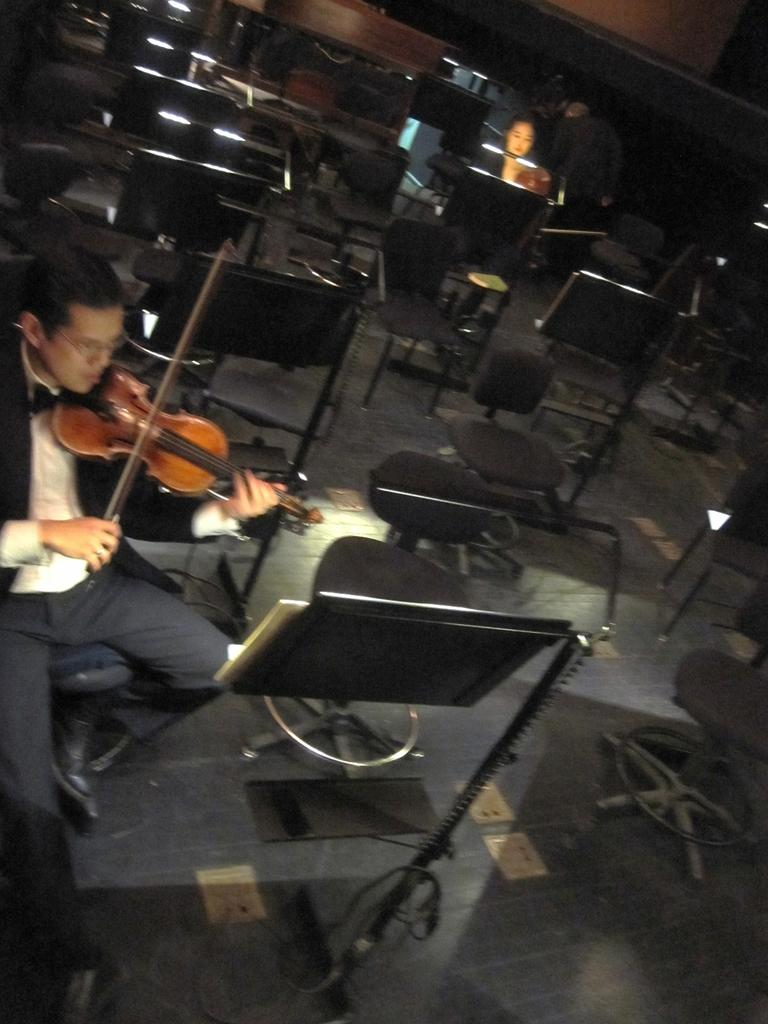What is the woman in the image doing? The woman is playing the violin in the image. Is the woman focused on anything while playing the violin? Yes, the woman is looking at a book while playing the violin. What can be seen in the background of the image? There are people and chairs in the background of the image. What type of tomatoes can be seen on the queen's throne in the image? There is no queen or tomatoes present in the image; it features a woman playing the violin and looking at a book. 